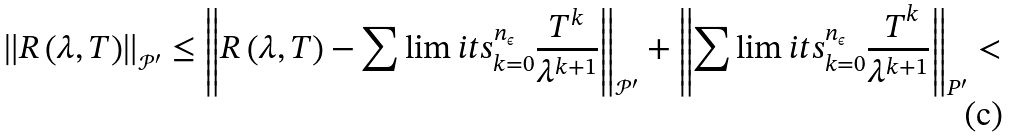<formula> <loc_0><loc_0><loc_500><loc_500>\left \| R \left ( \lambda , T \right ) \right \| _ { \mathcal { P } ^ { \prime } } \leq \left \| R \left ( \lambda , T \right ) - \sum \lim i t s _ { k = 0 } ^ { n _ { \epsilon } } \frac { { T } ^ { k } } { \lambda ^ { k + 1 } } \right \| _ { \mathcal { P } ^ { \prime } } + \left \| \sum \lim i t s _ { k = 0 } ^ { n _ { \epsilon } } \frac { { \ T } ^ { k } } { \lambda ^ { k + 1 } } \right \| _ { P ^ { \prime } } <</formula> 